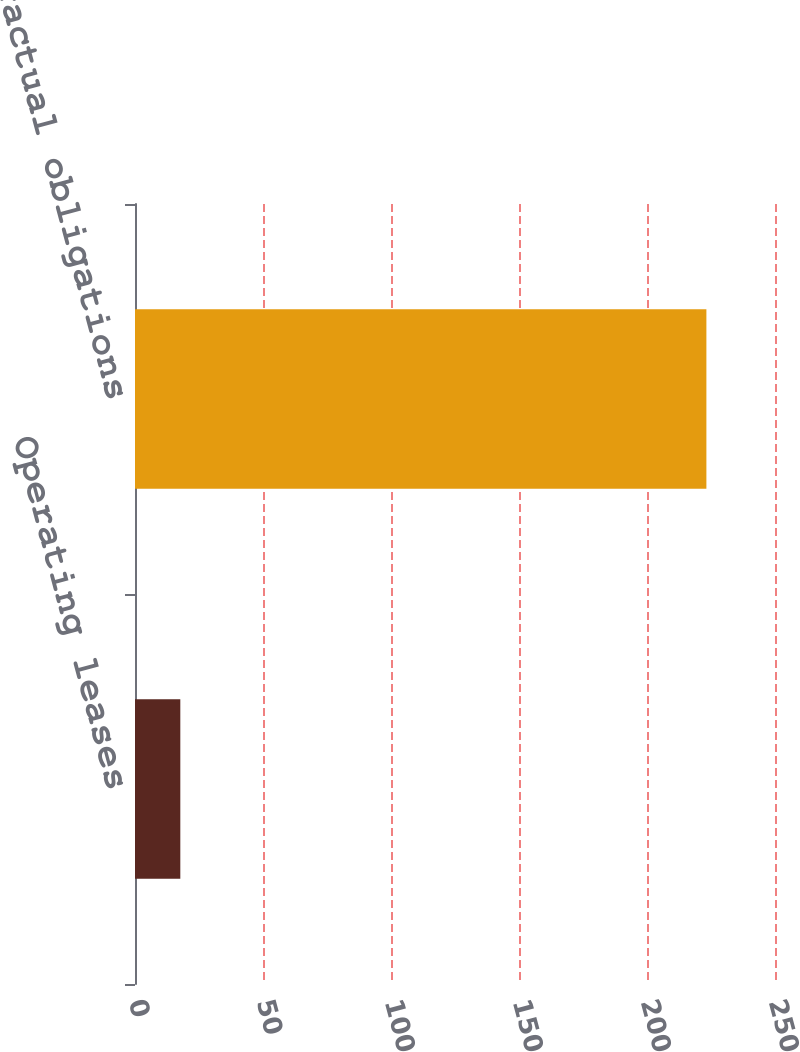Convert chart. <chart><loc_0><loc_0><loc_500><loc_500><bar_chart><fcel>Operating leases<fcel>Total contractual obligations<nl><fcel>17.7<fcel>223.2<nl></chart> 